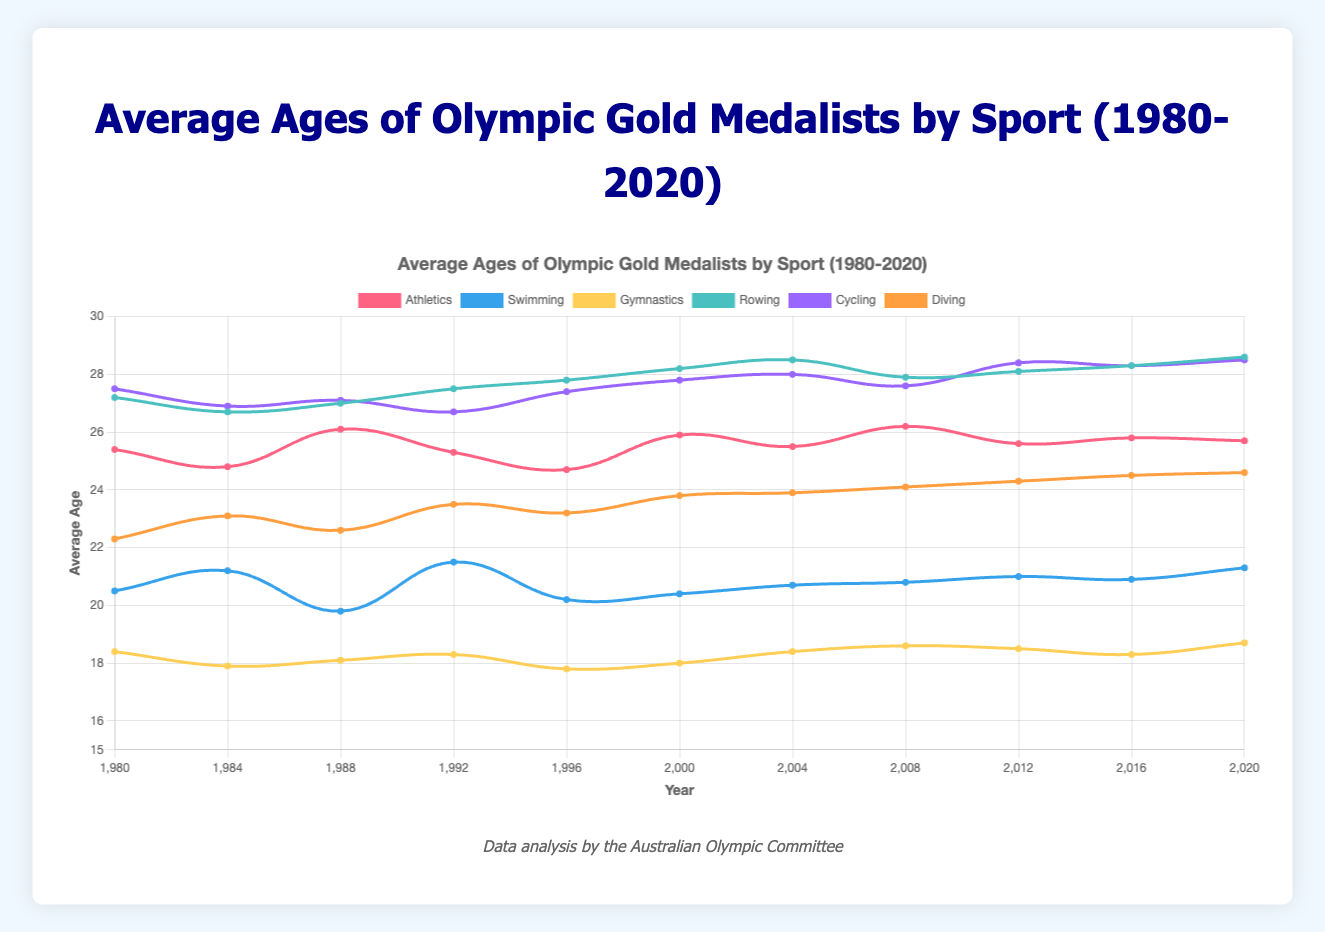What is the trend in the average age of gold medalists in Swimming from 1980 to 2020? From the chart, observe the line representing Swimming, which is typically blue. Note the increasing or decreasing pattern of the line from 1980 to 2020. The average age shows slight fluctuations but generally stays around the early 20s, ending at 21.3 in 2020.
Answer: Slight increase with fluctuations, ending at 21.3 in 2020 How does the average age of Gymnastics gold medalists in 2020 compare to that of Athletics in the same year? Locate the year 2020 on the x-axis, then find the corresponding points for both Gymnastics (usually a yellow line) and Athletics (typically a red line). Note their y-values for comparison. Gymnastics has an average age of 18.7, while Athletics has 25.7.
Answer: Gymnastics: 18.7, Athletics: 25.7 Which sport showed the greatest increase in the average age of gold medalists from 1980 to 2020? For each sport, compare the starting point in 1980 with the ending point in 2020. Calculate the differences and identify the sport with the largest increase. Rowing increased from 27.2 to 28.6, which is an increase of 1.4, the highest among all.
Answer: Rowing In which year did Athletics gold medalists have the highest average age, and what was it? Trace the line representing Athletics (red) and identify the highest point. Look at the x-axis to determine the year and the y-axis to note the average age. The highest average age is in 2008 at 26.2.
Answer: 2008, 26.2 Compare the average ages of Diving gold medalists between 1984 and 2020. What is the difference in their averages? Find the points for Diving in 1984 and 2020. The average age in 1984 is 23.1 and in 2020 is 24.6. Subtract the two to find the difference. 24.6 - 23.1 = 1.5
Answer: 1.5 Which sport had the most stable average age of gold medalists over the years? Evaluate the lines of each sport to identify the one with the least fluctuation. Gymnastics appears most stable as its line shows minimal changes around 18-19.
Answer: Gymnastics What is the average of the average ages of Cycling gold medalists in 1992 and 2012? Locate the points for Cycling in 1992 (26.7) and 2012 (28.4). Add these values and divide by 2. (26.7 + 28.4) / 2 = 27.55
Answer: 27.55 How much higher was the average age for Rowing gold medalists compared to Swimming in 2020? Find the average ages for Rowing (28.6) and Swimming (21.3) in 2020. Subtract the latter from the former. 28.6 - 21.3 = 7.3
Answer: 7.3 What is the difference in average ages between Athletics gold medalists in 1980 and Gymnastics gold medalists in 2020? Identify the points for Athletics in 1980 (25.4) and Gymnastics in 2020 (18.7). Calculate the difference. 25.4 - 18.7 = 6.7
Answer: 6.7 